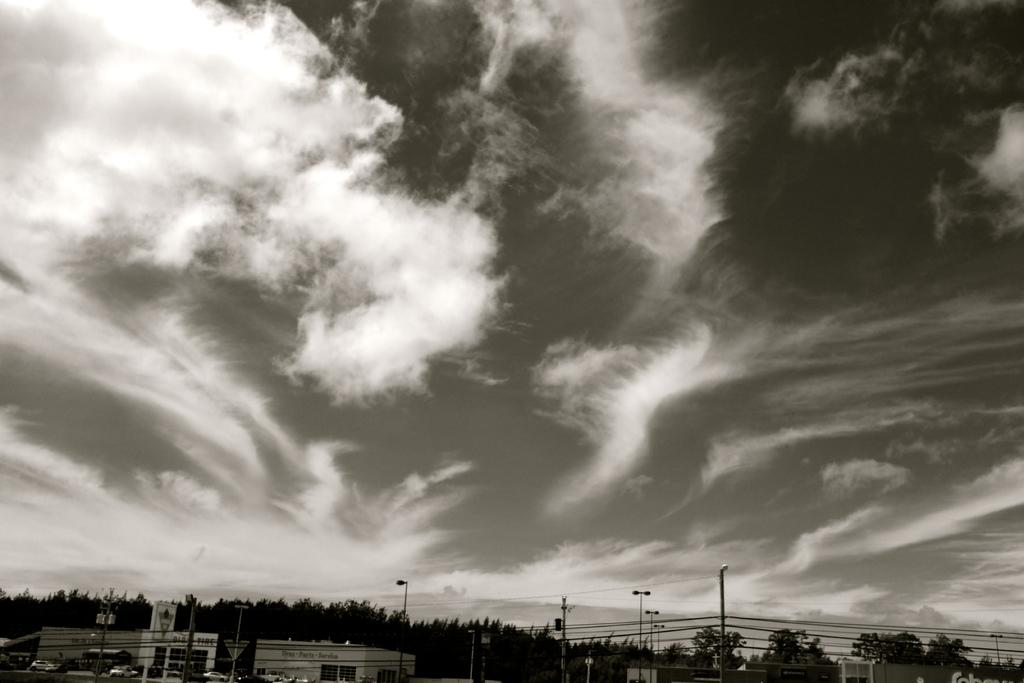What type of vegetation can be seen in the image? There are trees in the image. What is on the road in the image? There are cars on the road in the image. What else can be seen in the image besides trees and cars? There are poles and wires in the image. What is visible in the background of the image? The sky is visible in the background of the image. What can be observed in the sky? There are clouds in the sky. How many patches are visible on the train in the image? There is no train present in the image; it features trees, cars, poles, wires, and a sky with clouds. What type of fold can be seen in the image? There is no fold present in the image. 